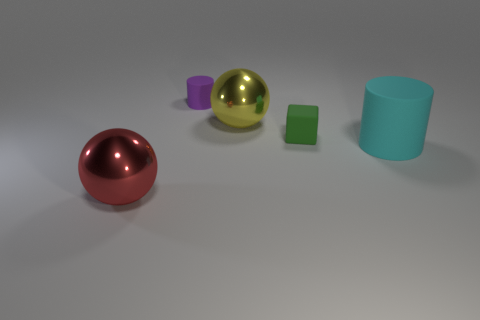Is the number of green matte blocks on the left side of the large cyan rubber thing less than the number of tiny rubber cubes?
Keep it short and to the point. No. Is there any other thing that is the same shape as the green thing?
Ensure brevity in your answer.  No. What is the color of the small thing that is the same shape as the big cyan matte thing?
Your answer should be compact. Purple. Is the size of the shiny ball that is to the right of the red thing the same as the tiny block?
Your answer should be very brief. No. There is a rubber cylinder that is to the right of the rubber cylinder that is left of the green block; what size is it?
Make the answer very short. Large. Is the material of the red ball the same as the big object on the right side of the small block?
Keep it short and to the point. No. Is the number of big cyan matte objects in front of the big red sphere less than the number of cylinders to the left of the small purple thing?
Ensure brevity in your answer.  No. What color is the other cylinder that is the same material as the purple cylinder?
Your response must be concise. Cyan. Are there any small purple cylinders to the left of the matte cylinder on the left side of the large cyan cylinder?
Offer a very short reply. No. What color is the cylinder that is the same size as the red object?
Offer a terse response. Cyan. 